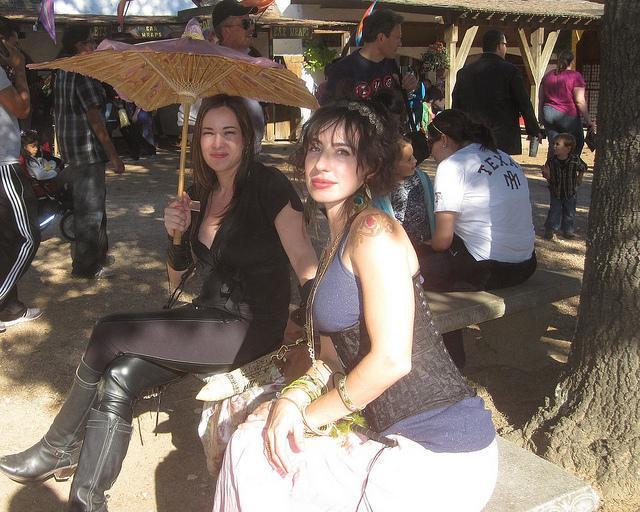How many benches are there?
Give a very brief answer. 2. How many people are in the photo?
Give a very brief answer. 11. 